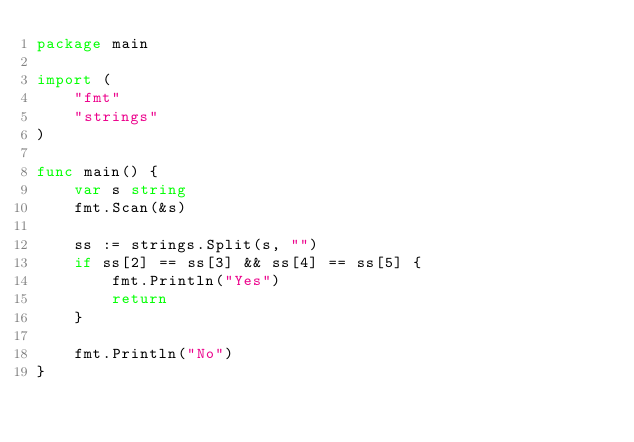<code> <loc_0><loc_0><loc_500><loc_500><_Go_>package main

import (
	"fmt"
	"strings"
)

func main() {
	var s string
	fmt.Scan(&s)

	ss := strings.Split(s, "")
	if ss[2] == ss[3] && ss[4] == ss[5] {
		fmt.Println("Yes")
		return
	}

	fmt.Println("No")
}
</code> 